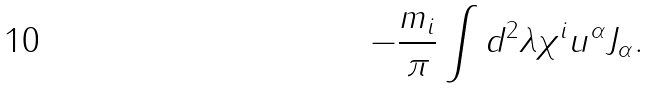<formula> <loc_0><loc_0><loc_500><loc_500>- \frac { m _ { i } } { \pi } \int d ^ { 2 } \lambda \chi ^ { i } u ^ { \alpha } J _ { \alpha } .</formula> 